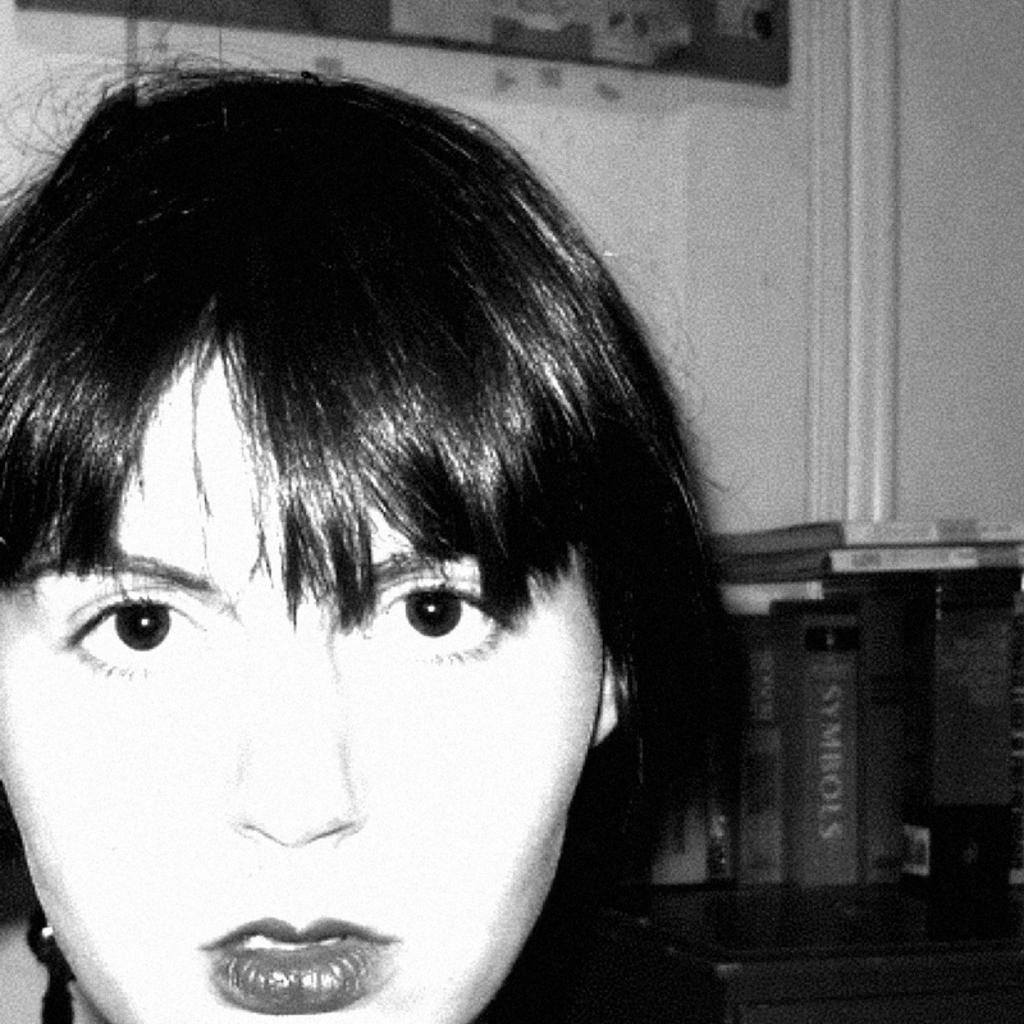What is the main subject of the image? There is a face in the image. What else can be seen in the image besides the face? There are books on a table in the image. What is the background of the image? There is a wall at the top of the image. What type of balloon is being held by the actor in the image? There is no actor or balloon present in the image. How many trays are visible on the table in the image? There are no trays visible on the table in the image. 